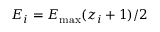Convert formula to latex. <formula><loc_0><loc_0><loc_500><loc_500>E _ { i } = E _ { \max } ( z _ { i } + 1 ) / 2</formula> 